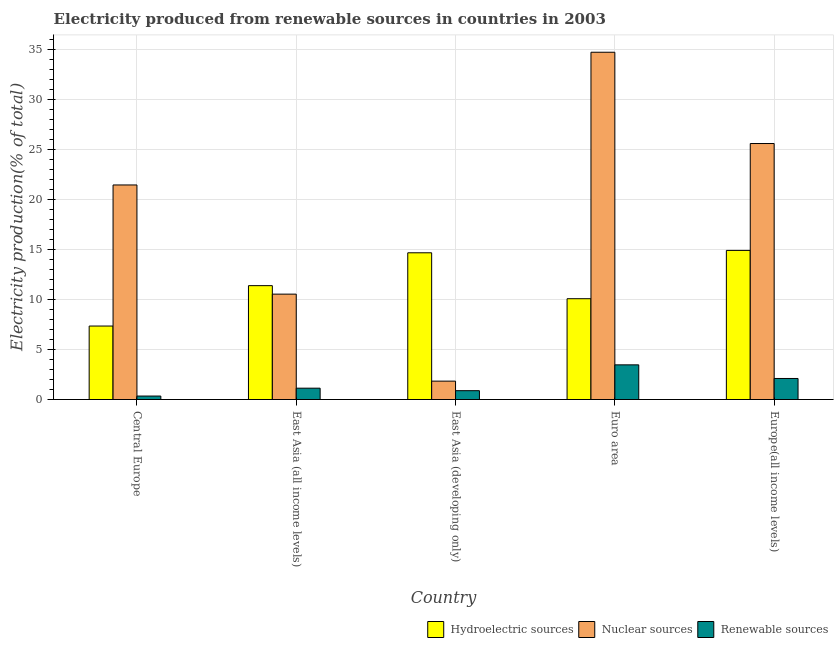How many different coloured bars are there?
Make the answer very short. 3. Are the number of bars on each tick of the X-axis equal?
Keep it short and to the point. Yes. How many bars are there on the 1st tick from the left?
Offer a very short reply. 3. What is the label of the 5th group of bars from the left?
Make the answer very short. Europe(all income levels). What is the percentage of electricity produced by nuclear sources in Euro area?
Provide a short and direct response. 34.74. Across all countries, what is the maximum percentage of electricity produced by nuclear sources?
Offer a terse response. 34.74. Across all countries, what is the minimum percentage of electricity produced by renewable sources?
Keep it short and to the point. 0.35. In which country was the percentage of electricity produced by renewable sources minimum?
Offer a very short reply. Central Europe. What is the total percentage of electricity produced by nuclear sources in the graph?
Offer a very short reply. 94.2. What is the difference between the percentage of electricity produced by hydroelectric sources in Central Europe and that in East Asia (developing only)?
Keep it short and to the point. -7.33. What is the difference between the percentage of electricity produced by renewable sources in Euro area and the percentage of electricity produced by hydroelectric sources in East Asia (all income levels)?
Offer a terse response. -7.92. What is the average percentage of electricity produced by hydroelectric sources per country?
Keep it short and to the point. 11.68. What is the difference between the percentage of electricity produced by hydroelectric sources and percentage of electricity produced by nuclear sources in Europe(all income levels)?
Keep it short and to the point. -10.69. What is the ratio of the percentage of electricity produced by hydroelectric sources in Central Europe to that in East Asia (developing only)?
Make the answer very short. 0.5. Is the percentage of electricity produced by hydroelectric sources in Euro area less than that in Europe(all income levels)?
Provide a succinct answer. Yes. Is the difference between the percentage of electricity produced by renewable sources in East Asia (developing only) and Euro area greater than the difference between the percentage of electricity produced by nuclear sources in East Asia (developing only) and Euro area?
Offer a terse response. Yes. What is the difference between the highest and the second highest percentage of electricity produced by hydroelectric sources?
Make the answer very short. 0.24. What is the difference between the highest and the lowest percentage of electricity produced by nuclear sources?
Your answer should be very brief. 32.9. Is the sum of the percentage of electricity produced by renewable sources in Central Europe and East Asia (developing only) greater than the maximum percentage of electricity produced by hydroelectric sources across all countries?
Offer a terse response. No. What does the 1st bar from the left in Euro area represents?
Your response must be concise. Hydroelectric sources. What does the 1st bar from the right in Euro area represents?
Your response must be concise. Renewable sources. Is it the case that in every country, the sum of the percentage of electricity produced by hydroelectric sources and percentage of electricity produced by nuclear sources is greater than the percentage of electricity produced by renewable sources?
Ensure brevity in your answer.  Yes. How many countries are there in the graph?
Make the answer very short. 5. What is the difference between two consecutive major ticks on the Y-axis?
Your answer should be compact. 5. Does the graph contain grids?
Your response must be concise. Yes. Where does the legend appear in the graph?
Make the answer very short. Bottom right. What is the title of the graph?
Your answer should be very brief. Electricity produced from renewable sources in countries in 2003. What is the label or title of the Y-axis?
Give a very brief answer. Electricity production(% of total). What is the Electricity production(% of total) of Hydroelectric sources in Central Europe?
Ensure brevity in your answer.  7.35. What is the Electricity production(% of total) in Nuclear sources in Central Europe?
Your answer should be very brief. 21.46. What is the Electricity production(% of total) of Renewable sources in Central Europe?
Give a very brief answer. 0.35. What is the Electricity production(% of total) of Hydroelectric sources in East Asia (all income levels)?
Your answer should be very brief. 11.39. What is the Electricity production(% of total) of Nuclear sources in East Asia (all income levels)?
Offer a very short reply. 10.54. What is the Electricity production(% of total) in Renewable sources in East Asia (all income levels)?
Give a very brief answer. 1.13. What is the Electricity production(% of total) of Hydroelectric sources in East Asia (developing only)?
Provide a short and direct response. 14.68. What is the Electricity production(% of total) of Nuclear sources in East Asia (developing only)?
Offer a very short reply. 1.84. What is the Electricity production(% of total) of Renewable sources in East Asia (developing only)?
Your response must be concise. 0.88. What is the Electricity production(% of total) in Hydroelectric sources in Euro area?
Keep it short and to the point. 10.09. What is the Electricity production(% of total) of Nuclear sources in Euro area?
Provide a short and direct response. 34.74. What is the Electricity production(% of total) of Renewable sources in Euro area?
Ensure brevity in your answer.  3.47. What is the Electricity production(% of total) in Hydroelectric sources in Europe(all income levels)?
Provide a short and direct response. 14.92. What is the Electricity production(% of total) in Nuclear sources in Europe(all income levels)?
Your response must be concise. 25.61. What is the Electricity production(% of total) of Renewable sources in Europe(all income levels)?
Ensure brevity in your answer.  2.11. Across all countries, what is the maximum Electricity production(% of total) of Hydroelectric sources?
Give a very brief answer. 14.92. Across all countries, what is the maximum Electricity production(% of total) of Nuclear sources?
Ensure brevity in your answer.  34.74. Across all countries, what is the maximum Electricity production(% of total) in Renewable sources?
Ensure brevity in your answer.  3.47. Across all countries, what is the minimum Electricity production(% of total) of Hydroelectric sources?
Ensure brevity in your answer.  7.35. Across all countries, what is the minimum Electricity production(% of total) of Nuclear sources?
Your response must be concise. 1.84. Across all countries, what is the minimum Electricity production(% of total) of Renewable sources?
Ensure brevity in your answer.  0.35. What is the total Electricity production(% of total) in Hydroelectric sources in the graph?
Provide a short and direct response. 58.42. What is the total Electricity production(% of total) of Nuclear sources in the graph?
Offer a terse response. 94.2. What is the total Electricity production(% of total) of Renewable sources in the graph?
Ensure brevity in your answer.  7.94. What is the difference between the Electricity production(% of total) of Hydroelectric sources in Central Europe and that in East Asia (all income levels)?
Your response must be concise. -4.04. What is the difference between the Electricity production(% of total) in Nuclear sources in Central Europe and that in East Asia (all income levels)?
Offer a terse response. 10.92. What is the difference between the Electricity production(% of total) of Renewable sources in Central Europe and that in East Asia (all income levels)?
Provide a short and direct response. -0.79. What is the difference between the Electricity production(% of total) of Hydroelectric sources in Central Europe and that in East Asia (developing only)?
Your response must be concise. -7.33. What is the difference between the Electricity production(% of total) of Nuclear sources in Central Europe and that in East Asia (developing only)?
Provide a succinct answer. 19.63. What is the difference between the Electricity production(% of total) in Renewable sources in Central Europe and that in East Asia (developing only)?
Provide a short and direct response. -0.54. What is the difference between the Electricity production(% of total) of Hydroelectric sources in Central Europe and that in Euro area?
Your answer should be compact. -2.74. What is the difference between the Electricity production(% of total) in Nuclear sources in Central Europe and that in Euro area?
Provide a short and direct response. -13.28. What is the difference between the Electricity production(% of total) of Renewable sources in Central Europe and that in Euro area?
Your answer should be compact. -3.12. What is the difference between the Electricity production(% of total) of Hydroelectric sources in Central Europe and that in Europe(all income levels)?
Keep it short and to the point. -7.57. What is the difference between the Electricity production(% of total) of Nuclear sources in Central Europe and that in Europe(all income levels)?
Offer a very short reply. -4.14. What is the difference between the Electricity production(% of total) in Renewable sources in Central Europe and that in Europe(all income levels)?
Offer a terse response. -1.76. What is the difference between the Electricity production(% of total) of Hydroelectric sources in East Asia (all income levels) and that in East Asia (developing only)?
Offer a terse response. -3.29. What is the difference between the Electricity production(% of total) in Nuclear sources in East Asia (all income levels) and that in East Asia (developing only)?
Your answer should be compact. 8.7. What is the difference between the Electricity production(% of total) of Renewable sources in East Asia (all income levels) and that in East Asia (developing only)?
Give a very brief answer. 0.25. What is the difference between the Electricity production(% of total) in Hydroelectric sources in East Asia (all income levels) and that in Euro area?
Offer a terse response. 1.31. What is the difference between the Electricity production(% of total) in Nuclear sources in East Asia (all income levels) and that in Euro area?
Your response must be concise. -24.2. What is the difference between the Electricity production(% of total) of Renewable sources in East Asia (all income levels) and that in Euro area?
Provide a short and direct response. -2.33. What is the difference between the Electricity production(% of total) of Hydroelectric sources in East Asia (all income levels) and that in Europe(all income levels)?
Offer a very short reply. -3.53. What is the difference between the Electricity production(% of total) in Nuclear sources in East Asia (all income levels) and that in Europe(all income levels)?
Your answer should be very brief. -15.07. What is the difference between the Electricity production(% of total) of Renewable sources in East Asia (all income levels) and that in Europe(all income levels)?
Provide a short and direct response. -0.97. What is the difference between the Electricity production(% of total) in Hydroelectric sources in East Asia (developing only) and that in Euro area?
Make the answer very short. 4.59. What is the difference between the Electricity production(% of total) in Nuclear sources in East Asia (developing only) and that in Euro area?
Your response must be concise. -32.9. What is the difference between the Electricity production(% of total) in Renewable sources in East Asia (developing only) and that in Euro area?
Provide a succinct answer. -2.58. What is the difference between the Electricity production(% of total) in Hydroelectric sources in East Asia (developing only) and that in Europe(all income levels)?
Provide a short and direct response. -0.24. What is the difference between the Electricity production(% of total) in Nuclear sources in East Asia (developing only) and that in Europe(all income levels)?
Your answer should be very brief. -23.77. What is the difference between the Electricity production(% of total) in Renewable sources in East Asia (developing only) and that in Europe(all income levels)?
Your answer should be very brief. -1.22. What is the difference between the Electricity production(% of total) in Hydroelectric sources in Euro area and that in Europe(all income levels)?
Give a very brief answer. -4.83. What is the difference between the Electricity production(% of total) in Nuclear sources in Euro area and that in Europe(all income levels)?
Give a very brief answer. 9.13. What is the difference between the Electricity production(% of total) of Renewable sources in Euro area and that in Europe(all income levels)?
Give a very brief answer. 1.36. What is the difference between the Electricity production(% of total) of Hydroelectric sources in Central Europe and the Electricity production(% of total) of Nuclear sources in East Asia (all income levels)?
Offer a terse response. -3.19. What is the difference between the Electricity production(% of total) in Hydroelectric sources in Central Europe and the Electricity production(% of total) in Renewable sources in East Asia (all income levels)?
Keep it short and to the point. 6.22. What is the difference between the Electricity production(% of total) in Nuclear sources in Central Europe and the Electricity production(% of total) in Renewable sources in East Asia (all income levels)?
Your answer should be very brief. 20.33. What is the difference between the Electricity production(% of total) of Hydroelectric sources in Central Europe and the Electricity production(% of total) of Nuclear sources in East Asia (developing only)?
Give a very brief answer. 5.51. What is the difference between the Electricity production(% of total) in Hydroelectric sources in Central Europe and the Electricity production(% of total) in Renewable sources in East Asia (developing only)?
Make the answer very short. 6.47. What is the difference between the Electricity production(% of total) of Nuclear sources in Central Europe and the Electricity production(% of total) of Renewable sources in East Asia (developing only)?
Provide a succinct answer. 20.58. What is the difference between the Electricity production(% of total) in Hydroelectric sources in Central Europe and the Electricity production(% of total) in Nuclear sources in Euro area?
Offer a very short reply. -27.39. What is the difference between the Electricity production(% of total) in Hydroelectric sources in Central Europe and the Electricity production(% of total) in Renewable sources in Euro area?
Your answer should be compact. 3.88. What is the difference between the Electricity production(% of total) of Nuclear sources in Central Europe and the Electricity production(% of total) of Renewable sources in Euro area?
Give a very brief answer. 18. What is the difference between the Electricity production(% of total) in Hydroelectric sources in Central Europe and the Electricity production(% of total) in Nuclear sources in Europe(all income levels)?
Give a very brief answer. -18.26. What is the difference between the Electricity production(% of total) in Hydroelectric sources in Central Europe and the Electricity production(% of total) in Renewable sources in Europe(all income levels)?
Your response must be concise. 5.24. What is the difference between the Electricity production(% of total) of Nuclear sources in Central Europe and the Electricity production(% of total) of Renewable sources in Europe(all income levels)?
Your answer should be very brief. 19.36. What is the difference between the Electricity production(% of total) in Hydroelectric sources in East Asia (all income levels) and the Electricity production(% of total) in Nuclear sources in East Asia (developing only)?
Give a very brief answer. 9.55. What is the difference between the Electricity production(% of total) of Hydroelectric sources in East Asia (all income levels) and the Electricity production(% of total) of Renewable sources in East Asia (developing only)?
Provide a short and direct response. 10.51. What is the difference between the Electricity production(% of total) of Nuclear sources in East Asia (all income levels) and the Electricity production(% of total) of Renewable sources in East Asia (developing only)?
Provide a succinct answer. 9.66. What is the difference between the Electricity production(% of total) in Hydroelectric sources in East Asia (all income levels) and the Electricity production(% of total) in Nuclear sources in Euro area?
Provide a short and direct response. -23.35. What is the difference between the Electricity production(% of total) of Hydroelectric sources in East Asia (all income levels) and the Electricity production(% of total) of Renewable sources in Euro area?
Your response must be concise. 7.92. What is the difference between the Electricity production(% of total) in Nuclear sources in East Asia (all income levels) and the Electricity production(% of total) in Renewable sources in Euro area?
Offer a very short reply. 7.08. What is the difference between the Electricity production(% of total) of Hydroelectric sources in East Asia (all income levels) and the Electricity production(% of total) of Nuclear sources in Europe(all income levels)?
Keep it short and to the point. -14.22. What is the difference between the Electricity production(% of total) of Hydroelectric sources in East Asia (all income levels) and the Electricity production(% of total) of Renewable sources in Europe(all income levels)?
Offer a terse response. 9.29. What is the difference between the Electricity production(% of total) of Nuclear sources in East Asia (all income levels) and the Electricity production(% of total) of Renewable sources in Europe(all income levels)?
Make the answer very short. 8.44. What is the difference between the Electricity production(% of total) in Hydroelectric sources in East Asia (developing only) and the Electricity production(% of total) in Nuclear sources in Euro area?
Your answer should be compact. -20.06. What is the difference between the Electricity production(% of total) in Hydroelectric sources in East Asia (developing only) and the Electricity production(% of total) in Renewable sources in Euro area?
Offer a very short reply. 11.21. What is the difference between the Electricity production(% of total) in Nuclear sources in East Asia (developing only) and the Electricity production(% of total) in Renewable sources in Euro area?
Offer a terse response. -1.63. What is the difference between the Electricity production(% of total) in Hydroelectric sources in East Asia (developing only) and the Electricity production(% of total) in Nuclear sources in Europe(all income levels)?
Provide a succinct answer. -10.93. What is the difference between the Electricity production(% of total) in Hydroelectric sources in East Asia (developing only) and the Electricity production(% of total) in Renewable sources in Europe(all income levels)?
Make the answer very short. 12.57. What is the difference between the Electricity production(% of total) of Nuclear sources in East Asia (developing only) and the Electricity production(% of total) of Renewable sources in Europe(all income levels)?
Offer a very short reply. -0.27. What is the difference between the Electricity production(% of total) of Hydroelectric sources in Euro area and the Electricity production(% of total) of Nuclear sources in Europe(all income levels)?
Your response must be concise. -15.52. What is the difference between the Electricity production(% of total) of Hydroelectric sources in Euro area and the Electricity production(% of total) of Renewable sources in Europe(all income levels)?
Offer a very short reply. 7.98. What is the difference between the Electricity production(% of total) in Nuclear sources in Euro area and the Electricity production(% of total) in Renewable sources in Europe(all income levels)?
Ensure brevity in your answer.  32.64. What is the average Electricity production(% of total) in Hydroelectric sources per country?
Ensure brevity in your answer.  11.68. What is the average Electricity production(% of total) of Nuclear sources per country?
Offer a terse response. 18.84. What is the average Electricity production(% of total) of Renewable sources per country?
Provide a succinct answer. 1.59. What is the difference between the Electricity production(% of total) in Hydroelectric sources and Electricity production(% of total) in Nuclear sources in Central Europe?
Offer a terse response. -14.11. What is the difference between the Electricity production(% of total) in Hydroelectric sources and Electricity production(% of total) in Renewable sources in Central Europe?
Your answer should be compact. 7. What is the difference between the Electricity production(% of total) of Nuclear sources and Electricity production(% of total) of Renewable sources in Central Europe?
Your response must be concise. 21.12. What is the difference between the Electricity production(% of total) of Hydroelectric sources and Electricity production(% of total) of Nuclear sources in East Asia (all income levels)?
Give a very brief answer. 0.85. What is the difference between the Electricity production(% of total) of Hydroelectric sources and Electricity production(% of total) of Renewable sources in East Asia (all income levels)?
Your response must be concise. 10.26. What is the difference between the Electricity production(% of total) of Nuclear sources and Electricity production(% of total) of Renewable sources in East Asia (all income levels)?
Keep it short and to the point. 9.41. What is the difference between the Electricity production(% of total) of Hydroelectric sources and Electricity production(% of total) of Nuclear sources in East Asia (developing only)?
Keep it short and to the point. 12.84. What is the difference between the Electricity production(% of total) of Hydroelectric sources and Electricity production(% of total) of Renewable sources in East Asia (developing only)?
Offer a terse response. 13.79. What is the difference between the Electricity production(% of total) in Nuclear sources and Electricity production(% of total) in Renewable sources in East Asia (developing only)?
Provide a short and direct response. 0.96. What is the difference between the Electricity production(% of total) in Hydroelectric sources and Electricity production(% of total) in Nuclear sources in Euro area?
Ensure brevity in your answer.  -24.66. What is the difference between the Electricity production(% of total) of Hydroelectric sources and Electricity production(% of total) of Renewable sources in Euro area?
Offer a terse response. 6.62. What is the difference between the Electricity production(% of total) in Nuclear sources and Electricity production(% of total) in Renewable sources in Euro area?
Provide a short and direct response. 31.27. What is the difference between the Electricity production(% of total) in Hydroelectric sources and Electricity production(% of total) in Nuclear sources in Europe(all income levels)?
Keep it short and to the point. -10.69. What is the difference between the Electricity production(% of total) in Hydroelectric sources and Electricity production(% of total) in Renewable sources in Europe(all income levels)?
Your answer should be compact. 12.81. What is the difference between the Electricity production(% of total) in Nuclear sources and Electricity production(% of total) in Renewable sources in Europe(all income levels)?
Provide a short and direct response. 23.5. What is the ratio of the Electricity production(% of total) of Hydroelectric sources in Central Europe to that in East Asia (all income levels)?
Provide a succinct answer. 0.65. What is the ratio of the Electricity production(% of total) in Nuclear sources in Central Europe to that in East Asia (all income levels)?
Provide a succinct answer. 2.04. What is the ratio of the Electricity production(% of total) in Renewable sources in Central Europe to that in East Asia (all income levels)?
Keep it short and to the point. 0.31. What is the ratio of the Electricity production(% of total) of Hydroelectric sources in Central Europe to that in East Asia (developing only)?
Your answer should be very brief. 0.5. What is the ratio of the Electricity production(% of total) of Nuclear sources in Central Europe to that in East Asia (developing only)?
Your response must be concise. 11.67. What is the ratio of the Electricity production(% of total) of Renewable sources in Central Europe to that in East Asia (developing only)?
Your response must be concise. 0.39. What is the ratio of the Electricity production(% of total) in Hydroelectric sources in Central Europe to that in Euro area?
Provide a short and direct response. 0.73. What is the ratio of the Electricity production(% of total) of Nuclear sources in Central Europe to that in Euro area?
Offer a terse response. 0.62. What is the ratio of the Electricity production(% of total) in Renewable sources in Central Europe to that in Euro area?
Your response must be concise. 0.1. What is the ratio of the Electricity production(% of total) of Hydroelectric sources in Central Europe to that in Europe(all income levels)?
Your answer should be compact. 0.49. What is the ratio of the Electricity production(% of total) of Nuclear sources in Central Europe to that in Europe(all income levels)?
Offer a terse response. 0.84. What is the ratio of the Electricity production(% of total) in Renewable sources in Central Europe to that in Europe(all income levels)?
Your answer should be very brief. 0.16. What is the ratio of the Electricity production(% of total) of Hydroelectric sources in East Asia (all income levels) to that in East Asia (developing only)?
Your answer should be very brief. 0.78. What is the ratio of the Electricity production(% of total) of Nuclear sources in East Asia (all income levels) to that in East Asia (developing only)?
Offer a terse response. 5.73. What is the ratio of the Electricity production(% of total) in Renewable sources in East Asia (all income levels) to that in East Asia (developing only)?
Keep it short and to the point. 1.28. What is the ratio of the Electricity production(% of total) in Hydroelectric sources in East Asia (all income levels) to that in Euro area?
Offer a very short reply. 1.13. What is the ratio of the Electricity production(% of total) of Nuclear sources in East Asia (all income levels) to that in Euro area?
Your response must be concise. 0.3. What is the ratio of the Electricity production(% of total) of Renewable sources in East Asia (all income levels) to that in Euro area?
Give a very brief answer. 0.33. What is the ratio of the Electricity production(% of total) in Hydroelectric sources in East Asia (all income levels) to that in Europe(all income levels)?
Offer a terse response. 0.76. What is the ratio of the Electricity production(% of total) of Nuclear sources in East Asia (all income levels) to that in Europe(all income levels)?
Your answer should be very brief. 0.41. What is the ratio of the Electricity production(% of total) of Renewable sources in East Asia (all income levels) to that in Europe(all income levels)?
Your response must be concise. 0.54. What is the ratio of the Electricity production(% of total) in Hydroelectric sources in East Asia (developing only) to that in Euro area?
Offer a very short reply. 1.46. What is the ratio of the Electricity production(% of total) of Nuclear sources in East Asia (developing only) to that in Euro area?
Give a very brief answer. 0.05. What is the ratio of the Electricity production(% of total) of Renewable sources in East Asia (developing only) to that in Euro area?
Provide a succinct answer. 0.25. What is the ratio of the Electricity production(% of total) in Nuclear sources in East Asia (developing only) to that in Europe(all income levels)?
Keep it short and to the point. 0.07. What is the ratio of the Electricity production(% of total) in Renewable sources in East Asia (developing only) to that in Europe(all income levels)?
Offer a terse response. 0.42. What is the ratio of the Electricity production(% of total) of Hydroelectric sources in Euro area to that in Europe(all income levels)?
Give a very brief answer. 0.68. What is the ratio of the Electricity production(% of total) of Nuclear sources in Euro area to that in Europe(all income levels)?
Offer a very short reply. 1.36. What is the ratio of the Electricity production(% of total) in Renewable sources in Euro area to that in Europe(all income levels)?
Your answer should be very brief. 1.65. What is the difference between the highest and the second highest Electricity production(% of total) in Hydroelectric sources?
Keep it short and to the point. 0.24. What is the difference between the highest and the second highest Electricity production(% of total) of Nuclear sources?
Provide a succinct answer. 9.13. What is the difference between the highest and the second highest Electricity production(% of total) of Renewable sources?
Your answer should be compact. 1.36. What is the difference between the highest and the lowest Electricity production(% of total) in Hydroelectric sources?
Provide a short and direct response. 7.57. What is the difference between the highest and the lowest Electricity production(% of total) in Nuclear sources?
Keep it short and to the point. 32.9. What is the difference between the highest and the lowest Electricity production(% of total) in Renewable sources?
Provide a succinct answer. 3.12. 